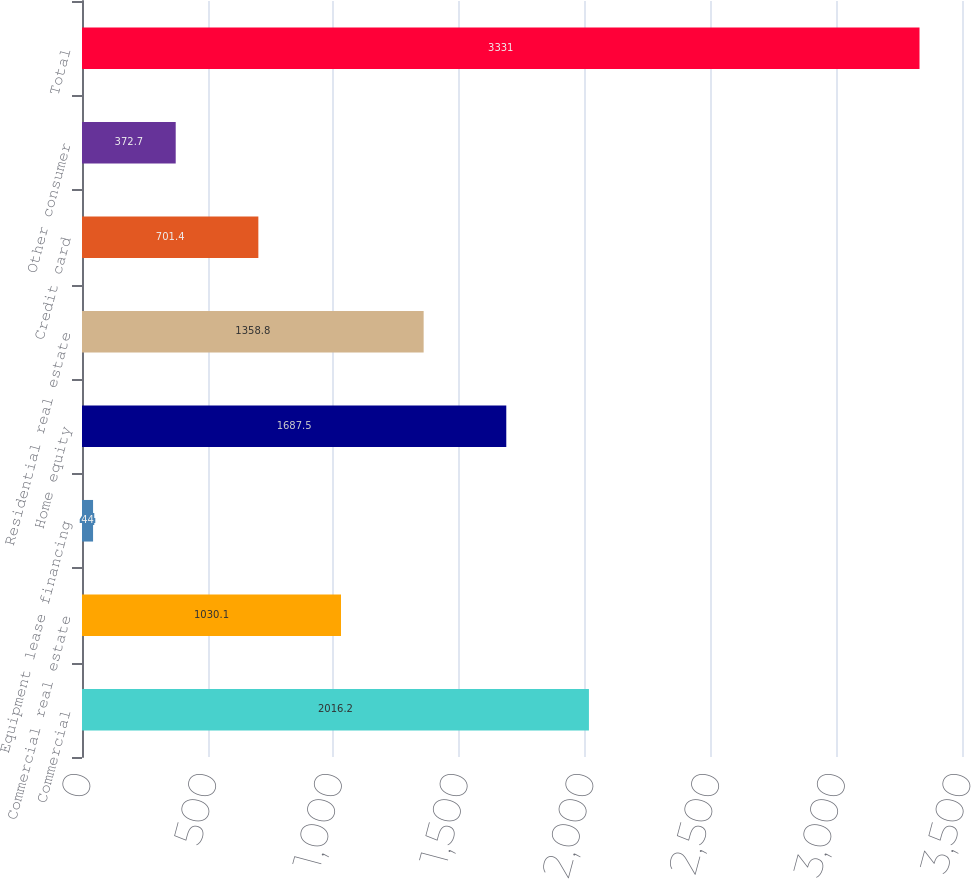Convert chart. <chart><loc_0><loc_0><loc_500><loc_500><bar_chart><fcel>Commercial<fcel>Commercial real estate<fcel>Equipment lease financing<fcel>Home equity<fcel>Residential real estate<fcel>Credit card<fcel>Other consumer<fcel>Total<nl><fcel>2016.2<fcel>1030.1<fcel>44<fcel>1687.5<fcel>1358.8<fcel>701.4<fcel>372.7<fcel>3331<nl></chart> 